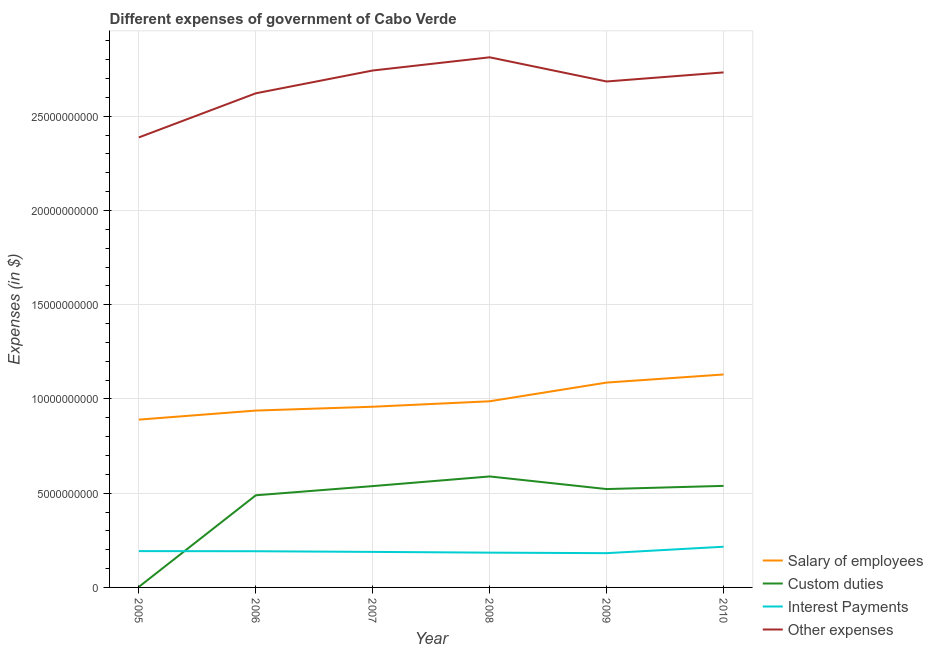Does the line corresponding to amount spent on interest payments intersect with the line corresponding to amount spent on salary of employees?
Offer a very short reply. No. Is the number of lines equal to the number of legend labels?
Offer a terse response. Yes. What is the amount spent on salary of employees in 2006?
Ensure brevity in your answer.  9.38e+09. Across all years, what is the maximum amount spent on custom duties?
Offer a very short reply. 5.89e+09. Across all years, what is the minimum amount spent on custom duties?
Offer a very short reply. 2.89e+07. In which year was the amount spent on custom duties minimum?
Make the answer very short. 2005. What is the total amount spent on salary of employees in the graph?
Your response must be concise. 5.99e+1. What is the difference between the amount spent on salary of employees in 2005 and that in 2006?
Offer a terse response. -4.81e+08. What is the difference between the amount spent on other expenses in 2005 and the amount spent on custom duties in 2008?
Make the answer very short. 1.80e+1. What is the average amount spent on custom duties per year?
Make the answer very short. 4.46e+09. In the year 2009, what is the difference between the amount spent on other expenses and amount spent on interest payments?
Your answer should be very brief. 2.50e+1. What is the ratio of the amount spent on interest payments in 2005 to that in 2007?
Offer a very short reply. 1.02. Is the amount spent on interest payments in 2005 less than that in 2007?
Make the answer very short. No. What is the difference between the highest and the second highest amount spent on interest payments?
Provide a short and direct response. 2.32e+08. What is the difference between the highest and the lowest amount spent on interest payments?
Your answer should be very brief. 3.41e+08. Is the sum of the amount spent on interest payments in 2008 and 2009 greater than the maximum amount spent on custom duties across all years?
Provide a short and direct response. No. Is it the case that in every year, the sum of the amount spent on salary of employees and amount spent on custom duties is greater than the amount spent on interest payments?
Make the answer very short. Yes. Does the amount spent on salary of employees monotonically increase over the years?
Offer a terse response. Yes. Is the amount spent on salary of employees strictly greater than the amount spent on interest payments over the years?
Keep it short and to the point. Yes. How many years are there in the graph?
Your response must be concise. 6. What is the difference between two consecutive major ticks on the Y-axis?
Your answer should be very brief. 5.00e+09. Does the graph contain any zero values?
Your answer should be compact. No. How are the legend labels stacked?
Provide a short and direct response. Vertical. What is the title of the graph?
Provide a succinct answer. Different expenses of government of Cabo Verde. What is the label or title of the X-axis?
Provide a succinct answer. Year. What is the label or title of the Y-axis?
Your answer should be compact. Expenses (in $). What is the Expenses (in $) of Salary of employees in 2005?
Ensure brevity in your answer.  8.90e+09. What is the Expenses (in $) in Custom duties in 2005?
Offer a terse response. 2.89e+07. What is the Expenses (in $) in Interest Payments in 2005?
Make the answer very short. 1.93e+09. What is the Expenses (in $) in Other expenses in 2005?
Make the answer very short. 2.39e+1. What is the Expenses (in $) in Salary of employees in 2006?
Make the answer very short. 9.38e+09. What is the Expenses (in $) in Custom duties in 2006?
Provide a succinct answer. 4.89e+09. What is the Expenses (in $) in Interest Payments in 2006?
Your answer should be very brief. 1.92e+09. What is the Expenses (in $) in Other expenses in 2006?
Offer a terse response. 2.62e+1. What is the Expenses (in $) of Salary of employees in 2007?
Keep it short and to the point. 9.59e+09. What is the Expenses (in $) of Custom duties in 2007?
Provide a short and direct response. 5.38e+09. What is the Expenses (in $) in Interest Payments in 2007?
Ensure brevity in your answer.  1.89e+09. What is the Expenses (in $) in Other expenses in 2007?
Offer a terse response. 2.74e+1. What is the Expenses (in $) in Salary of employees in 2008?
Provide a succinct answer. 9.88e+09. What is the Expenses (in $) of Custom duties in 2008?
Give a very brief answer. 5.89e+09. What is the Expenses (in $) of Interest Payments in 2008?
Your answer should be very brief. 1.85e+09. What is the Expenses (in $) in Other expenses in 2008?
Offer a very short reply. 2.81e+1. What is the Expenses (in $) of Salary of employees in 2009?
Make the answer very short. 1.09e+1. What is the Expenses (in $) in Custom duties in 2009?
Your answer should be very brief. 5.22e+09. What is the Expenses (in $) of Interest Payments in 2009?
Your answer should be very brief. 1.82e+09. What is the Expenses (in $) of Other expenses in 2009?
Provide a short and direct response. 2.68e+1. What is the Expenses (in $) of Salary of employees in 2010?
Give a very brief answer. 1.13e+1. What is the Expenses (in $) of Custom duties in 2010?
Ensure brevity in your answer.  5.39e+09. What is the Expenses (in $) in Interest Payments in 2010?
Your answer should be very brief. 2.16e+09. What is the Expenses (in $) in Other expenses in 2010?
Your answer should be compact. 2.73e+1. Across all years, what is the maximum Expenses (in $) of Salary of employees?
Offer a very short reply. 1.13e+1. Across all years, what is the maximum Expenses (in $) of Custom duties?
Give a very brief answer. 5.89e+09. Across all years, what is the maximum Expenses (in $) in Interest Payments?
Your answer should be compact. 2.16e+09. Across all years, what is the maximum Expenses (in $) in Other expenses?
Your answer should be very brief. 2.81e+1. Across all years, what is the minimum Expenses (in $) of Salary of employees?
Provide a succinct answer. 8.90e+09. Across all years, what is the minimum Expenses (in $) of Custom duties?
Offer a terse response. 2.89e+07. Across all years, what is the minimum Expenses (in $) in Interest Payments?
Your answer should be compact. 1.82e+09. Across all years, what is the minimum Expenses (in $) in Other expenses?
Provide a succinct answer. 2.39e+1. What is the total Expenses (in $) in Salary of employees in the graph?
Offer a terse response. 5.99e+1. What is the total Expenses (in $) of Custom duties in the graph?
Make the answer very short. 2.68e+1. What is the total Expenses (in $) of Interest Payments in the graph?
Keep it short and to the point. 1.16e+1. What is the total Expenses (in $) of Other expenses in the graph?
Provide a succinct answer. 1.60e+11. What is the difference between the Expenses (in $) in Salary of employees in 2005 and that in 2006?
Ensure brevity in your answer.  -4.81e+08. What is the difference between the Expenses (in $) of Custom duties in 2005 and that in 2006?
Keep it short and to the point. -4.86e+09. What is the difference between the Expenses (in $) in Interest Payments in 2005 and that in 2006?
Provide a short and direct response. 7.14e+06. What is the difference between the Expenses (in $) in Other expenses in 2005 and that in 2006?
Your answer should be compact. -2.34e+09. What is the difference between the Expenses (in $) in Salary of employees in 2005 and that in 2007?
Offer a terse response. -6.84e+08. What is the difference between the Expenses (in $) of Custom duties in 2005 and that in 2007?
Offer a very short reply. -5.35e+09. What is the difference between the Expenses (in $) of Interest Payments in 2005 and that in 2007?
Give a very brief answer. 4.18e+07. What is the difference between the Expenses (in $) of Other expenses in 2005 and that in 2007?
Provide a short and direct response. -3.55e+09. What is the difference between the Expenses (in $) in Salary of employees in 2005 and that in 2008?
Provide a succinct answer. -9.74e+08. What is the difference between the Expenses (in $) in Custom duties in 2005 and that in 2008?
Give a very brief answer. -5.86e+09. What is the difference between the Expenses (in $) in Interest Payments in 2005 and that in 2008?
Give a very brief answer. 8.17e+07. What is the difference between the Expenses (in $) of Other expenses in 2005 and that in 2008?
Give a very brief answer. -4.25e+09. What is the difference between the Expenses (in $) of Salary of employees in 2005 and that in 2009?
Offer a terse response. -1.97e+09. What is the difference between the Expenses (in $) of Custom duties in 2005 and that in 2009?
Make the answer very short. -5.19e+09. What is the difference between the Expenses (in $) of Interest Payments in 2005 and that in 2009?
Your answer should be very brief. 1.09e+08. What is the difference between the Expenses (in $) of Other expenses in 2005 and that in 2009?
Your answer should be compact. -2.97e+09. What is the difference between the Expenses (in $) of Salary of employees in 2005 and that in 2010?
Offer a terse response. -2.39e+09. What is the difference between the Expenses (in $) in Custom duties in 2005 and that in 2010?
Offer a terse response. -5.36e+09. What is the difference between the Expenses (in $) in Interest Payments in 2005 and that in 2010?
Provide a short and direct response. -2.32e+08. What is the difference between the Expenses (in $) in Other expenses in 2005 and that in 2010?
Offer a very short reply. -3.45e+09. What is the difference between the Expenses (in $) of Salary of employees in 2006 and that in 2007?
Give a very brief answer. -2.03e+08. What is the difference between the Expenses (in $) in Custom duties in 2006 and that in 2007?
Keep it short and to the point. -4.88e+08. What is the difference between the Expenses (in $) of Interest Payments in 2006 and that in 2007?
Offer a terse response. 3.47e+07. What is the difference between the Expenses (in $) of Other expenses in 2006 and that in 2007?
Make the answer very short. -1.21e+09. What is the difference between the Expenses (in $) in Salary of employees in 2006 and that in 2008?
Provide a succinct answer. -4.93e+08. What is the difference between the Expenses (in $) in Custom duties in 2006 and that in 2008?
Your response must be concise. -9.99e+08. What is the difference between the Expenses (in $) in Interest Payments in 2006 and that in 2008?
Give a very brief answer. 7.45e+07. What is the difference between the Expenses (in $) of Other expenses in 2006 and that in 2008?
Your answer should be very brief. -1.91e+09. What is the difference between the Expenses (in $) of Salary of employees in 2006 and that in 2009?
Provide a short and direct response. -1.49e+09. What is the difference between the Expenses (in $) in Custom duties in 2006 and that in 2009?
Your answer should be very brief. -3.30e+08. What is the difference between the Expenses (in $) in Interest Payments in 2006 and that in 2009?
Your response must be concise. 1.02e+08. What is the difference between the Expenses (in $) of Other expenses in 2006 and that in 2009?
Give a very brief answer. -6.27e+08. What is the difference between the Expenses (in $) of Salary of employees in 2006 and that in 2010?
Make the answer very short. -1.91e+09. What is the difference between the Expenses (in $) of Custom duties in 2006 and that in 2010?
Offer a terse response. -5.00e+08. What is the difference between the Expenses (in $) of Interest Payments in 2006 and that in 2010?
Give a very brief answer. -2.39e+08. What is the difference between the Expenses (in $) of Other expenses in 2006 and that in 2010?
Offer a terse response. -1.11e+09. What is the difference between the Expenses (in $) of Salary of employees in 2007 and that in 2008?
Provide a succinct answer. -2.90e+08. What is the difference between the Expenses (in $) in Custom duties in 2007 and that in 2008?
Your response must be concise. -5.12e+08. What is the difference between the Expenses (in $) in Interest Payments in 2007 and that in 2008?
Provide a short and direct response. 3.98e+07. What is the difference between the Expenses (in $) of Other expenses in 2007 and that in 2008?
Make the answer very short. -7.00e+08. What is the difference between the Expenses (in $) in Salary of employees in 2007 and that in 2009?
Your answer should be very brief. -1.28e+09. What is the difference between the Expenses (in $) of Custom duties in 2007 and that in 2009?
Provide a short and direct response. 1.57e+08. What is the difference between the Expenses (in $) of Interest Payments in 2007 and that in 2009?
Your response must be concise. 6.70e+07. What is the difference between the Expenses (in $) in Other expenses in 2007 and that in 2009?
Provide a short and direct response. 5.83e+08. What is the difference between the Expenses (in $) in Salary of employees in 2007 and that in 2010?
Your answer should be very brief. -1.71e+09. What is the difference between the Expenses (in $) of Custom duties in 2007 and that in 2010?
Your answer should be compact. -1.21e+07. What is the difference between the Expenses (in $) of Interest Payments in 2007 and that in 2010?
Give a very brief answer. -2.74e+08. What is the difference between the Expenses (in $) of Other expenses in 2007 and that in 2010?
Ensure brevity in your answer.  1.01e+08. What is the difference between the Expenses (in $) in Salary of employees in 2008 and that in 2009?
Offer a terse response. -9.92e+08. What is the difference between the Expenses (in $) in Custom duties in 2008 and that in 2009?
Offer a very short reply. 6.69e+08. What is the difference between the Expenses (in $) of Interest Payments in 2008 and that in 2009?
Your answer should be very brief. 2.72e+07. What is the difference between the Expenses (in $) of Other expenses in 2008 and that in 2009?
Keep it short and to the point. 1.28e+09. What is the difference between the Expenses (in $) of Salary of employees in 2008 and that in 2010?
Offer a very short reply. -1.42e+09. What is the difference between the Expenses (in $) in Custom duties in 2008 and that in 2010?
Offer a very short reply. 5.00e+08. What is the difference between the Expenses (in $) of Interest Payments in 2008 and that in 2010?
Keep it short and to the point. -3.14e+08. What is the difference between the Expenses (in $) of Other expenses in 2008 and that in 2010?
Provide a short and direct response. 8.02e+08. What is the difference between the Expenses (in $) of Salary of employees in 2009 and that in 2010?
Your answer should be very brief. -4.29e+08. What is the difference between the Expenses (in $) of Custom duties in 2009 and that in 2010?
Make the answer very short. -1.69e+08. What is the difference between the Expenses (in $) of Interest Payments in 2009 and that in 2010?
Keep it short and to the point. -3.41e+08. What is the difference between the Expenses (in $) in Other expenses in 2009 and that in 2010?
Keep it short and to the point. -4.81e+08. What is the difference between the Expenses (in $) of Salary of employees in 2005 and the Expenses (in $) of Custom duties in 2006?
Make the answer very short. 4.01e+09. What is the difference between the Expenses (in $) in Salary of employees in 2005 and the Expenses (in $) in Interest Payments in 2006?
Make the answer very short. 6.98e+09. What is the difference between the Expenses (in $) of Salary of employees in 2005 and the Expenses (in $) of Other expenses in 2006?
Make the answer very short. -1.73e+1. What is the difference between the Expenses (in $) in Custom duties in 2005 and the Expenses (in $) in Interest Payments in 2006?
Your answer should be very brief. -1.89e+09. What is the difference between the Expenses (in $) in Custom duties in 2005 and the Expenses (in $) in Other expenses in 2006?
Provide a short and direct response. -2.62e+1. What is the difference between the Expenses (in $) in Interest Payments in 2005 and the Expenses (in $) in Other expenses in 2006?
Offer a very short reply. -2.43e+1. What is the difference between the Expenses (in $) of Salary of employees in 2005 and the Expenses (in $) of Custom duties in 2007?
Your answer should be compact. 3.53e+09. What is the difference between the Expenses (in $) in Salary of employees in 2005 and the Expenses (in $) in Interest Payments in 2007?
Keep it short and to the point. 7.02e+09. What is the difference between the Expenses (in $) in Salary of employees in 2005 and the Expenses (in $) in Other expenses in 2007?
Keep it short and to the point. -1.85e+1. What is the difference between the Expenses (in $) in Custom duties in 2005 and the Expenses (in $) in Interest Payments in 2007?
Provide a short and direct response. -1.86e+09. What is the difference between the Expenses (in $) of Custom duties in 2005 and the Expenses (in $) of Other expenses in 2007?
Provide a short and direct response. -2.74e+1. What is the difference between the Expenses (in $) of Interest Payments in 2005 and the Expenses (in $) of Other expenses in 2007?
Make the answer very short. -2.55e+1. What is the difference between the Expenses (in $) of Salary of employees in 2005 and the Expenses (in $) of Custom duties in 2008?
Offer a very short reply. 3.02e+09. What is the difference between the Expenses (in $) of Salary of employees in 2005 and the Expenses (in $) of Interest Payments in 2008?
Your answer should be compact. 7.06e+09. What is the difference between the Expenses (in $) in Salary of employees in 2005 and the Expenses (in $) in Other expenses in 2008?
Provide a succinct answer. -1.92e+1. What is the difference between the Expenses (in $) in Custom duties in 2005 and the Expenses (in $) in Interest Payments in 2008?
Your response must be concise. -1.82e+09. What is the difference between the Expenses (in $) in Custom duties in 2005 and the Expenses (in $) in Other expenses in 2008?
Your answer should be very brief. -2.81e+1. What is the difference between the Expenses (in $) of Interest Payments in 2005 and the Expenses (in $) of Other expenses in 2008?
Your answer should be very brief. -2.62e+1. What is the difference between the Expenses (in $) in Salary of employees in 2005 and the Expenses (in $) in Custom duties in 2009?
Make the answer very short. 3.68e+09. What is the difference between the Expenses (in $) of Salary of employees in 2005 and the Expenses (in $) of Interest Payments in 2009?
Offer a very short reply. 7.09e+09. What is the difference between the Expenses (in $) in Salary of employees in 2005 and the Expenses (in $) in Other expenses in 2009?
Provide a succinct answer. -1.79e+1. What is the difference between the Expenses (in $) of Custom duties in 2005 and the Expenses (in $) of Interest Payments in 2009?
Your answer should be very brief. -1.79e+09. What is the difference between the Expenses (in $) of Custom duties in 2005 and the Expenses (in $) of Other expenses in 2009?
Your response must be concise. -2.68e+1. What is the difference between the Expenses (in $) in Interest Payments in 2005 and the Expenses (in $) in Other expenses in 2009?
Your answer should be very brief. -2.49e+1. What is the difference between the Expenses (in $) of Salary of employees in 2005 and the Expenses (in $) of Custom duties in 2010?
Offer a terse response. 3.51e+09. What is the difference between the Expenses (in $) of Salary of employees in 2005 and the Expenses (in $) of Interest Payments in 2010?
Your response must be concise. 6.74e+09. What is the difference between the Expenses (in $) of Salary of employees in 2005 and the Expenses (in $) of Other expenses in 2010?
Offer a terse response. -1.84e+1. What is the difference between the Expenses (in $) of Custom duties in 2005 and the Expenses (in $) of Interest Payments in 2010?
Give a very brief answer. -2.13e+09. What is the difference between the Expenses (in $) of Custom duties in 2005 and the Expenses (in $) of Other expenses in 2010?
Provide a succinct answer. -2.73e+1. What is the difference between the Expenses (in $) in Interest Payments in 2005 and the Expenses (in $) in Other expenses in 2010?
Your answer should be very brief. -2.54e+1. What is the difference between the Expenses (in $) in Salary of employees in 2006 and the Expenses (in $) in Custom duties in 2007?
Provide a succinct answer. 4.01e+09. What is the difference between the Expenses (in $) of Salary of employees in 2006 and the Expenses (in $) of Interest Payments in 2007?
Your response must be concise. 7.50e+09. What is the difference between the Expenses (in $) of Salary of employees in 2006 and the Expenses (in $) of Other expenses in 2007?
Offer a very short reply. -1.80e+1. What is the difference between the Expenses (in $) of Custom duties in 2006 and the Expenses (in $) of Interest Payments in 2007?
Offer a terse response. 3.00e+09. What is the difference between the Expenses (in $) in Custom duties in 2006 and the Expenses (in $) in Other expenses in 2007?
Give a very brief answer. -2.25e+1. What is the difference between the Expenses (in $) in Interest Payments in 2006 and the Expenses (in $) in Other expenses in 2007?
Give a very brief answer. -2.55e+1. What is the difference between the Expenses (in $) in Salary of employees in 2006 and the Expenses (in $) in Custom duties in 2008?
Keep it short and to the point. 3.50e+09. What is the difference between the Expenses (in $) in Salary of employees in 2006 and the Expenses (in $) in Interest Payments in 2008?
Provide a succinct answer. 7.54e+09. What is the difference between the Expenses (in $) of Salary of employees in 2006 and the Expenses (in $) of Other expenses in 2008?
Your answer should be compact. -1.87e+1. What is the difference between the Expenses (in $) of Custom duties in 2006 and the Expenses (in $) of Interest Payments in 2008?
Provide a succinct answer. 3.04e+09. What is the difference between the Expenses (in $) of Custom duties in 2006 and the Expenses (in $) of Other expenses in 2008?
Offer a terse response. -2.32e+1. What is the difference between the Expenses (in $) in Interest Payments in 2006 and the Expenses (in $) in Other expenses in 2008?
Your answer should be very brief. -2.62e+1. What is the difference between the Expenses (in $) in Salary of employees in 2006 and the Expenses (in $) in Custom duties in 2009?
Your answer should be very brief. 4.16e+09. What is the difference between the Expenses (in $) in Salary of employees in 2006 and the Expenses (in $) in Interest Payments in 2009?
Your answer should be very brief. 7.57e+09. What is the difference between the Expenses (in $) in Salary of employees in 2006 and the Expenses (in $) in Other expenses in 2009?
Offer a very short reply. -1.75e+1. What is the difference between the Expenses (in $) of Custom duties in 2006 and the Expenses (in $) of Interest Payments in 2009?
Make the answer very short. 3.07e+09. What is the difference between the Expenses (in $) of Custom duties in 2006 and the Expenses (in $) of Other expenses in 2009?
Ensure brevity in your answer.  -2.20e+1. What is the difference between the Expenses (in $) in Interest Payments in 2006 and the Expenses (in $) in Other expenses in 2009?
Your response must be concise. -2.49e+1. What is the difference between the Expenses (in $) of Salary of employees in 2006 and the Expenses (in $) of Custom duties in 2010?
Ensure brevity in your answer.  4.00e+09. What is the difference between the Expenses (in $) of Salary of employees in 2006 and the Expenses (in $) of Interest Payments in 2010?
Ensure brevity in your answer.  7.22e+09. What is the difference between the Expenses (in $) in Salary of employees in 2006 and the Expenses (in $) in Other expenses in 2010?
Your answer should be compact. -1.79e+1. What is the difference between the Expenses (in $) of Custom duties in 2006 and the Expenses (in $) of Interest Payments in 2010?
Provide a succinct answer. 2.73e+09. What is the difference between the Expenses (in $) in Custom duties in 2006 and the Expenses (in $) in Other expenses in 2010?
Provide a short and direct response. -2.24e+1. What is the difference between the Expenses (in $) of Interest Payments in 2006 and the Expenses (in $) of Other expenses in 2010?
Your response must be concise. -2.54e+1. What is the difference between the Expenses (in $) in Salary of employees in 2007 and the Expenses (in $) in Custom duties in 2008?
Your answer should be very brief. 3.70e+09. What is the difference between the Expenses (in $) in Salary of employees in 2007 and the Expenses (in $) in Interest Payments in 2008?
Make the answer very short. 7.74e+09. What is the difference between the Expenses (in $) in Salary of employees in 2007 and the Expenses (in $) in Other expenses in 2008?
Offer a very short reply. -1.85e+1. What is the difference between the Expenses (in $) of Custom duties in 2007 and the Expenses (in $) of Interest Payments in 2008?
Provide a short and direct response. 3.53e+09. What is the difference between the Expenses (in $) of Custom duties in 2007 and the Expenses (in $) of Other expenses in 2008?
Make the answer very short. -2.28e+1. What is the difference between the Expenses (in $) of Interest Payments in 2007 and the Expenses (in $) of Other expenses in 2008?
Make the answer very short. -2.62e+1. What is the difference between the Expenses (in $) in Salary of employees in 2007 and the Expenses (in $) in Custom duties in 2009?
Ensure brevity in your answer.  4.37e+09. What is the difference between the Expenses (in $) in Salary of employees in 2007 and the Expenses (in $) in Interest Payments in 2009?
Your answer should be compact. 7.77e+09. What is the difference between the Expenses (in $) in Salary of employees in 2007 and the Expenses (in $) in Other expenses in 2009?
Ensure brevity in your answer.  -1.73e+1. What is the difference between the Expenses (in $) of Custom duties in 2007 and the Expenses (in $) of Interest Payments in 2009?
Ensure brevity in your answer.  3.56e+09. What is the difference between the Expenses (in $) of Custom duties in 2007 and the Expenses (in $) of Other expenses in 2009?
Offer a very short reply. -2.15e+1. What is the difference between the Expenses (in $) of Interest Payments in 2007 and the Expenses (in $) of Other expenses in 2009?
Offer a terse response. -2.50e+1. What is the difference between the Expenses (in $) in Salary of employees in 2007 and the Expenses (in $) in Custom duties in 2010?
Your answer should be very brief. 4.20e+09. What is the difference between the Expenses (in $) in Salary of employees in 2007 and the Expenses (in $) in Interest Payments in 2010?
Offer a terse response. 7.43e+09. What is the difference between the Expenses (in $) in Salary of employees in 2007 and the Expenses (in $) in Other expenses in 2010?
Make the answer very short. -1.77e+1. What is the difference between the Expenses (in $) of Custom duties in 2007 and the Expenses (in $) of Interest Payments in 2010?
Ensure brevity in your answer.  3.22e+09. What is the difference between the Expenses (in $) in Custom duties in 2007 and the Expenses (in $) in Other expenses in 2010?
Offer a very short reply. -2.19e+1. What is the difference between the Expenses (in $) of Interest Payments in 2007 and the Expenses (in $) of Other expenses in 2010?
Offer a terse response. -2.54e+1. What is the difference between the Expenses (in $) in Salary of employees in 2008 and the Expenses (in $) in Custom duties in 2009?
Make the answer very short. 4.66e+09. What is the difference between the Expenses (in $) of Salary of employees in 2008 and the Expenses (in $) of Interest Payments in 2009?
Ensure brevity in your answer.  8.06e+09. What is the difference between the Expenses (in $) in Salary of employees in 2008 and the Expenses (in $) in Other expenses in 2009?
Your response must be concise. -1.70e+1. What is the difference between the Expenses (in $) in Custom duties in 2008 and the Expenses (in $) in Interest Payments in 2009?
Keep it short and to the point. 4.07e+09. What is the difference between the Expenses (in $) of Custom duties in 2008 and the Expenses (in $) of Other expenses in 2009?
Your answer should be compact. -2.10e+1. What is the difference between the Expenses (in $) of Interest Payments in 2008 and the Expenses (in $) of Other expenses in 2009?
Provide a succinct answer. -2.50e+1. What is the difference between the Expenses (in $) of Salary of employees in 2008 and the Expenses (in $) of Custom duties in 2010?
Offer a terse response. 4.49e+09. What is the difference between the Expenses (in $) of Salary of employees in 2008 and the Expenses (in $) of Interest Payments in 2010?
Give a very brief answer. 7.72e+09. What is the difference between the Expenses (in $) of Salary of employees in 2008 and the Expenses (in $) of Other expenses in 2010?
Provide a succinct answer. -1.74e+1. What is the difference between the Expenses (in $) of Custom duties in 2008 and the Expenses (in $) of Interest Payments in 2010?
Your response must be concise. 3.73e+09. What is the difference between the Expenses (in $) of Custom duties in 2008 and the Expenses (in $) of Other expenses in 2010?
Provide a succinct answer. -2.14e+1. What is the difference between the Expenses (in $) in Interest Payments in 2008 and the Expenses (in $) in Other expenses in 2010?
Make the answer very short. -2.55e+1. What is the difference between the Expenses (in $) of Salary of employees in 2009 and the Expenses (in $) of Custom duties in 2010?
Your response must be concise. 5.48e+09. What is the difference between the Expenses (in $) of Salary of employees in 2009 and the Expenses (in $) of Interest Payments in 2010?
Make the answer very short. 8.71e+09. What is the difference between the Expenses (in $) of Salary of employees in 2009 and the Expenses (in $) of Other expenses in 2010?
Offer a terse response. -1.65e+1. What is the difference between the Expenses (in $) of Custom duties in 2009 and the Expenses (in $) of Interest Payments in 2010?
Your response must be concise. 3.06e+09. What is the difference between the Expenses (in $) of Custom duties in 2009 and the Expenses (in $) of Other expenses in 2010?
Ensure brevity in your answer.  -2.21e+1. What is the difference between the Expenses (in $) in Interest Payments in 2009 and the Expenses (in $) in Other expenses in 2010?
Your answer should be very brief. -2.55e+1. What is the average Expenses (in $) of Salary of employees per year?
Your response must be concise. 9.99e+09. What is the average Expenses (in $) of Custom duties per year?
Your response must be concise. 4.46e+09. What is the average Expenses (in $) in Interest Payments per year?
Offer a very short reply. 1.93e+09. What is the average Expenses (in $) in Other expenses per year?
Provide a succinct answer. 2.66e+1. In the year 2005, what is the difference between the Expenses (in $) of Salary of employees and Expenses (in $) of Custom duties?
Keep it short and to the point. 8.87e+09. In the year 2005, what is the difference between the Expenses (in $) in Salary of employees and Expenses (in $) in Interest Payments?
Provide a succinct answer. 6.98e+09. In the year 2005, what is the difference between the Expenses (in $) in Salary of employees and Expenses (in $) in Other expenses?
Offer a terse response. -1.50e+1. In the year 2005, what is the difference between the Expenses (in $) of Custom duties and Expenses (in $) of Interest Payments?
Provide a succinct answer. -1.90e+09. In the year 2005, what is the difference between the Expenses (in $) in Custom duties and Expenses (in $) in Other expenses?
Provide a succinct answer. -2.38e+1. In the year 2005, what is the difference between the Expenses (in $) in Interest Payments and Expenses (in $) in Other expenses?
Provide a short and direct response. -2.19e+1. In the year 2006, what is the difference between the Expenses (in $) in Salary of employees and Expenses (in $) in Custom duties?
Make the answer very short. 4.50e+09. In the year 2006, what is the difference between the Expenses (in $) of Salary of employees and Expenses (in $) of Interest Payments?
Provide a succinct answer. 7.46e+09. In the year 2006, what is the difference between the Expenses (in $) of Salary of employees and Expenses (in $) of Other expenses?
Your response must be concise. -1.68e+1. In the year 2006, what is the difference between the Expenses (in $) of Custom duties and Expenses (in $) of Interest Payments?
Your answer should be compact. 2.97e+09. In the year 2006, what is the difference between the Expenses (in $) in Custom duties and Expenses (in $) in Other expenses?
Keep it short and to the point. -2.13e+1. In the year 2006, what is the difference between the Expenses (in $) of Interest Payments and Expenses (in $) of Other expenses?
Your answer should be compact. -2.43e+1. In the year 2007, what is the difference between the Expenses (in $) of Salary of employees and Expenses (in $) of Custom duties?
Your response must be concise. 4.21e+09. In the year 2007, what is the difference between the Expenses (in $) in Salary of employees and Expenses (in $) in Interest Payments?
Your answer should be compact. 7.70e+09. In the year 2007, what is the difference between the Expenses (in $) in Salary of employees and Expenses (in $) in Other expenses?
Offer a terse response. -1.78e+1. In the year 2007, what is the difference between the Expenses (in $) of Custom duties and Expenses (in $) of Interest Payments?
Make the answer very short. 3.49e+09. In the year 2007, what is the difference between the Expenses (in $) of Custom duties and Expenses (in $) of Other expenses?
Your answer should be compact. -2.21e+1. In the year 2007, what is the difference between the Expenses (in $) of Interest Payments and Expenses (in $) of Other expenses?
Provide a short and direct response. -2.55e+1. In the year 2008, what is the difference between the Expenses (in $) of Salary of employees and Expenses (in $) of Custom duties?
Your answer should be compact. 3.99e+09. In the year 2008, what is the difference between the Expenses (in $) in Salary of employees and Expenses (in $) in Interest Payments?
Ensure brevity in your answer.  8.03e+09. In the year 2008, what is the difference between the Expenses (in $) of Salary of employees and Expenses (in $) of Other expenses?
Provide a short and direct response. -1.83e+1. In the year 2008, what is the difference between the Expenses (in $) in Custom duties and Expenses (in $) in Interest Payments?
Make the answer very short. 4.04e+09. In the year 2008, what is the difference between the Expenses (in $) of Custom duties and Expenses (in $) of Other expenses?
Your answer should be compact. -2.22e+1. In the year 2008, what is the difference between the Expenses (in $) in Interest Payments and Expenses (in $) in Other expenses?
Make the answer very short. -2.63e+1. In the year 2009, what is the difference between the Expenses (in $) in Salary of employees and Expenses (in $) in Custom duties?
Provide a short and direct response. 5.65e+09. In the year 2009, what is the difference between the Expenses (in $) of Salary of employees and Expenses (in $) of Interest Payments?
Your answer should be very brief. 9.05e+09. In the year 2009, what is the difference between the Expenses (in $) in Salary of employees and Expenses (in $) in Other expenses?
Provide a succinct answer. -1.60e+1. In the year 2009, what is the difference between the Expenses (in $) of Custom duties and Expenses (in $) of Interest Payments?
Offer a terse response. 3.40e+09. In the year 2009, what is the difference between the Expenses (in $) of Custom duties and Expenses (in $) of Other expenses?
Your response must be concise. -2.16e+1. In the year 2009, what is the difference between the Expenses (in $) in Interest Payments and Expenses (in $) in Other expenses?
Ensure brevity in your answer.  -2.50e+1. In the year 2010, what is the difference between the Expenses (in $) in Salary of employees and Expenses (in $) in Custom duties?
Keep it short and to the point. 5.91e+09. In the year 2010, what is the difference between the Expenses (in $) of Salary of employees and Expenses (in $) of Interest Payments?
Your response must be concise. 9.14e+09. In the year 2010, what is the difference between the Expenses (in $) in Salary of employees and Expenses (in $) in Other expenses?
Give a very brief answer. -1.60e+1. In the year 2010, what is the difference between the Expenses (in $) in Custom duties and Expenses (in $) in Interest Payments?
Offer a terse response. 3.23e+09. In the year 2010, what is the difference between the Expenses (in $) of Custom duties and Expenses (in $) of Other expenses?
Your response must be concise. -2.19e+1. In the year 2010, what is the difference between the Expenses (in $) in Interest Payments and Expenses (in $) in Other expenses?
Your answer should be very brief. -2.52e+1. What is the ratio of the Expenses (in $) in Salary of employees in 2005 to that in 2006?
Your answer should be compact. 0.95. What is the ratio of the Expenses (in $) in Custom duties in 2005 to that in 2006?
Keep it short and to the point. 0.01. What is the ratio of the Expenses (in $) of Interest Payments in 2005 to that in 2006?
Your answer should be compact. 1. What is the ratio of the Expenses (in $) in Other expenses in 2005 to that in 2006?
Make the answer very short. 0.91. What is the ratio of the Expenses (in $) of Salary of employees in 2005 to that in 2007?
Your answer should be compact. 0.93. What is the ratio of the Expenses (in $) in Custom duties in 2005 to that in 2007?
Your answer should be very brief. 0.01. What is the ratio of the Expenses (in $) of Interest Payments in 2005 to that in 2007?
Offer a terse response. 1.02. What is the ratio of the Expenses (in $) of Other expenses in 2005 to that in 2007?
Ensure brevity in your answer.  0.87. What is the ratio of the Expenses (in $) in Salary of employees in 2005 to that in 2008?
Keep it short and to the point. 0.9. What is the ratio of the Expenses (in $) of Custom duties in 2005 to that in 2008?
Give a very brief answer. 0. What is the ratio of the Expenses (in $) of Interest Payments in 2005 to that in 2008?
Provide a short and direct response. 1.04. What is the ratio of the Expenses (in $) in Other expenses in 2005 to that in 2008?
Make the answer very short. 0.85. What is the ratio of the Expenses (in $) of Salary of employees in 2005 to that in 2009?
Your response must be concise. 0.82. What is the ratio of the Expenses (in $) in Custom duties in 2005 to that in 2009?
Your answer should be compact. 0.01. What is the ratio of the Expenses (in $) in Interest Payments in 2005 to that in 2009?
Offer a terse response. 1.06. What is the ratio of the Expenses (in $) of Other expenses in 2005 to that in 2009?
Offer a very short reply. 0.89. What is the ratio of the Expenses (in $) in Salary of employees in 2005 to that in 2010?
Your response must be concise. 0.79. What is the ratio of the Expenses (in $) of Custom duties in 2005 to that in 2010?
Make the answer very short. 0.01. What is the ratio of the Expenses (in $) in Interest Payments in 2005 to that in 2010?
Make the answer very short. 0.89. What is the ratio of the Expenses (in $) of Other expenses in 2005 to that in 2010?
Offer a terse response. 0.87. What is the ratio of the Expenses (in $) of Salary of employees in 2006 to that in 2007?
Your answer should be very brief. 0.98. What is the ratio of the Expenses (in $) in Custom duties in 2006 to that in 2007?
Provide a short and direct response. 0.91. What is the ratio of the Expenses (in $) in Interest Payments in 2006 to that in 2007?
Make the answer very short. 1.02. What is the ratio of the Expenses (in $) of Other expenses in 2006 to that in 2007?
Your answer should be compact. 0.96. What is the ratio of the Expenses (in $) in Salary of employees in 2006 to that in 2008?
Offer a terse response. 0.95. What is the ratio of the Expenses (in $) of Custom duties in 2006 to that in 2008?
Your response must be concise. 0.83. What is the ratio of the Expenses (in $) in Interest Payments in 2006 to that in 2008?
Your answer should be very brief. 1.04. What is the ratio of the Expenses (in $) in Other expenses in 2006 to that in 2008?
Keep it short and to the point. 0.93. What is the ratio of the Expenses (in $) in Salary of employees in 2006 to that in 2009?
Provide a succinct answer. 0.86. What is the ratio of the Expenses (in $) of Custom duties in 2006 to that in 2009?
Your response must be concise. 0.94. What is the ratio of the Expenses (in $) of Interest Payments in 2006 to that in 2009?
Your response must be concise. 1.06. What is the ratio of the Expenses (in $) of Other expenses in 2006 to that in 2009?
Offer a terse response. 0.98. What is the ratio of the Expenses (in $) of Salary of employees in 2006 to that in 2010?
Your response must be concise. 0.83. What is the ratio of the Expenses (in $) of Custom duties in 2006 to that in 2010?
Provide a short and direct response. 0.91. What is the ratio of the Expenses (in $) in Interest Payments in 2006 to that in 2010?
Offer a very short reply. 0.89. What is the ratio of the Expenses (in $) in Other expenses in 2006 to that in 2010?
Give a very brief answer. 0.96. What is the ratio of the Expenses (in $) in Salary of employees in 2007 to that in 2008?
Your answer should be compact. 0.97. What is the ratio of the Expenses (in $) in Custom duties in 2007 to that in 2008?
Offer a terse response. 0.91. What is the ratio of the Expenses (in $) in Interest Payments in 2007 to that in 2008?
Provide a succinct answer. 1.02. What is the ratio of the Expenses (in $) in Other expenses in 2007 to that in 2008?
Keep it short and to the point. 0.98. What is the ratio of the Expenses (in $) in Salary of employees in 2007 to that in 2009?
Make the answer very short. 0.88. What is the ratio of the Expenses (in $) of Custom duties in 2007 to that in 2009?
Give a very brief answer. 1.03. What is the ratio of the Expenses (in $) in Interest Payments in 2007 to that in 2009?
Your response must be concise. 1.04. What is the ratio of the Expenses (in $) of Other expenses in 2007 to that in 2009?
Offer a very short reply. 1.02. What is the ratio of the Expenses (in $) of Salary of employees in 2007 to that in 2010?
Offer a very short reply. 0.85. What is the ratio of the Expenses (in $) in Interest Payments in 2007 to that in 2010?
Give a very brief answer. 0.87. What is the ratio of the Expenses (in $) of Salary of employees in 2008 to that in 2009?
Keep it short and to the point. 0.91. What is the ratio of the Expenses (in $) in Custom duties in 2008 to that in 2009?
Make the answer very short. 1.13. What is the ratio of the Expenses (in $) of Interest Payments in 2008 to that in 2009?
Your answer should be compact. 1.01. What is the ratio of the Expenses (in $) of Other expenses in 2008 to that in 2009?
Give a very brief answer. 1.05. What is the ratio of the Expenses (in $) of Salary of employees in 2008 to that in 2010?
Offer a terse response. 0.87. What is the ratio of the Expenses (in $) of Custom duties in 2008 to that in 2010?
Ensure brevity in your answer.  1.09. What is the ratio of the Expenses (in $) in Interest Payments in 2008 to that in 2010?
Ensure brevity in your answer.  0.85. What is the ratio of the Expenses (in $) in Other expenses in 2008 to that in 2010?
Offer a terse response. 1.03. What is the ratio of the Expenses (in $) in Salary of employees in 2009 to that in 2010?
Ensure brevity in your answer.  0.96. What is the ratio of the Expenses (in $) in Custom duties in 2009 to that in 2010?
Keep it short and to the point. 0.97. What is the ratio of the Expenses (in $) of Interest Payments in 2009 to that in 2010?
Make the answer very short. 0.84. What is the ratio of the Expenses (in $) in Other expenses in 2009 to that in 2010?
Keep it short and to the point. 0.98. What is the difference between the highest and the second highest Expenses (in $) of Salary of employees?
Provide a succinct answer. 4.29e+08. What is the difference between the highest and the second highest Expenses (in $) of Custom duties?
Provide a succinct answer. 5.00e+08. What is the difference between the highest and the second highest Expenses (in $) in Interest Payments?
Offer a terse response. 2.32e+08. What is the difference between the highest and the second highest Expenses (in $) of Other expenses?
Offer a terse response. 7.00e+08. What is the difference between the highest and the lowest Expenses (in $) of Salary of employees?
Provide a short and direct response. 2.39e+09. What is the difference between the highest and the lowest Expenses (in $) in Custom duties?
Your answer should be very brief. 5.86e+09. What is the difference between the highest and the lowest Expenses (in $) of Interest Payments?
Give a very brief answer. 3.41e+08. What is the difference between the highest and the lowest Expenses (in $) of Other expenses?
Give a very brief answer. 4.25e+09. 